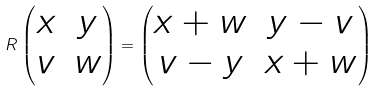Convert formula to latex. <formula><loc_0><loc_0><loc_500><loc_500>R \begin{pmatrix} x & y \\ v & w \end{pmatrix} = \begin{pmatrix} x + w & y - v \\ v - y & x + w \end{pmatrix}</formula> 